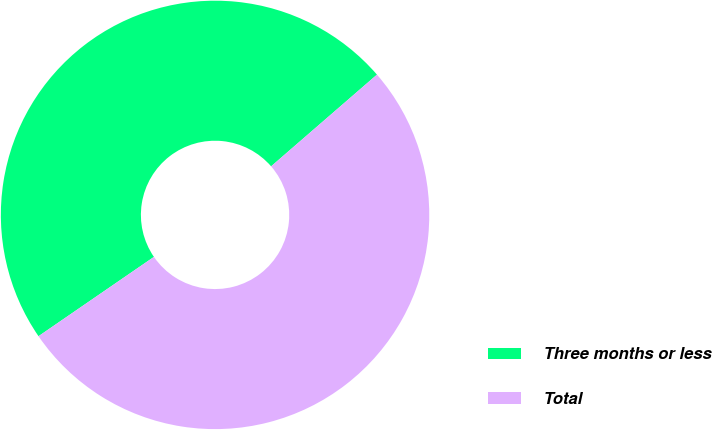Convert chart to OTSL. <chart><loc_0><loc_0><loc_500><loc_500><pie_chart><fcel>Three months or less<fcel>Total<nl><fcel>48.22%<fcel>51.78%<nl></chart> 